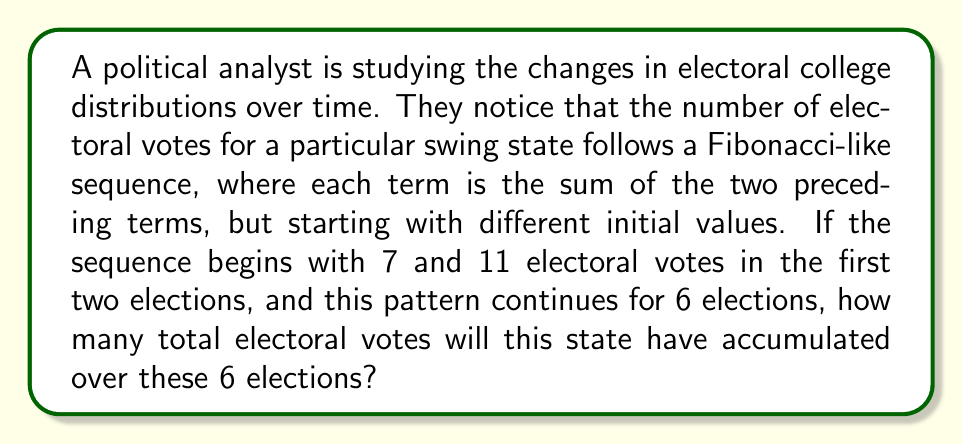Help me with this question. Let's approach this step-by-step:

1) First, let's write out the Fibonacci-like sequence for the 6 elections:

   Election 1: 7 electoral votes
   Election 2: 11 electoral votes
   Election 3: $7 + 11 = 18$ electoral votes
   Election 4: $11 + 18 = 29$ electoral votes
   Election 5: $18 + 29 = 47$ electoral votes
   Election 6: $29 + 47 = 76$ electoral votes

2) Now, we need to sum all these values to get the total electoral votes over the 6 elections:

   $$ \text{Total} = 7 + 11 + 18 + 29 + 47 + 76 $$

3) Let's calculate this sum:

   $$ \text{Total} = 188 $$

Therefore, the state will have accumulated 188 electoral votes over these 6 elections.
Answer: 188 electoral votes 